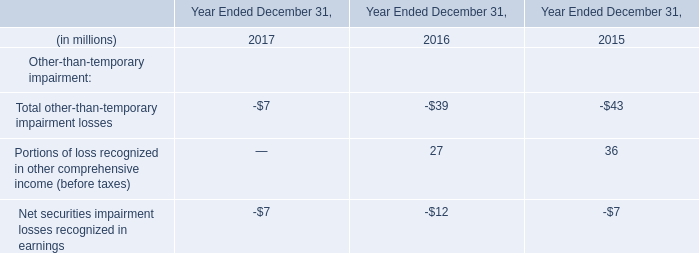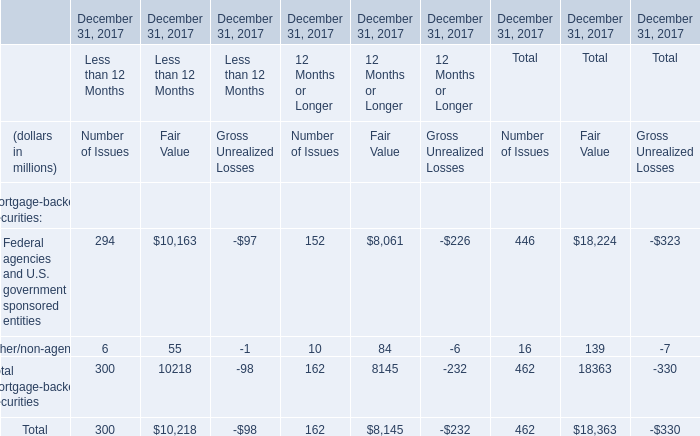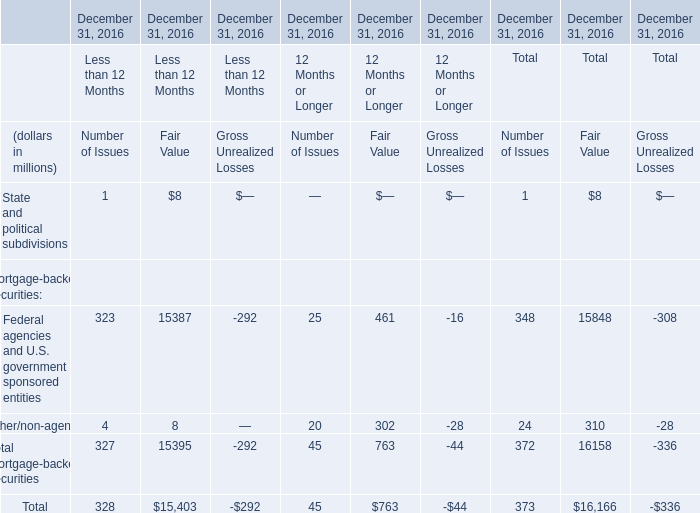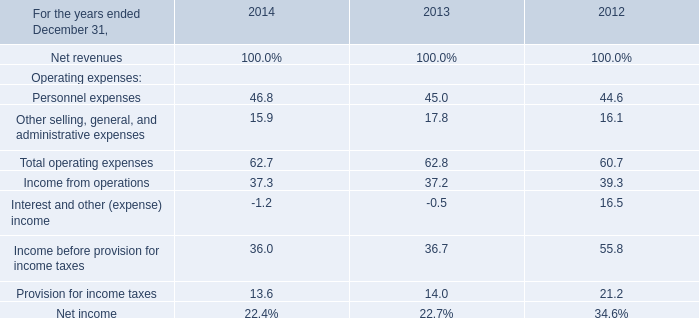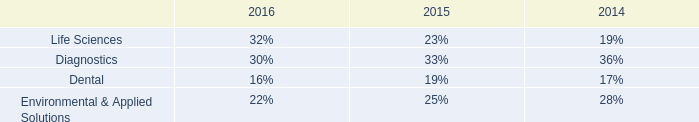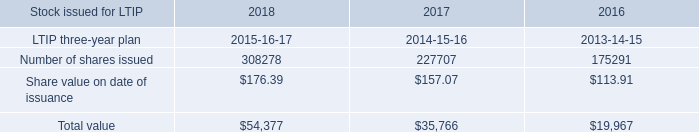What's the 1% of total Fair Value in 2016? (in million) 
Computations: (16166 * 0.01)
Answer: 161.66. 